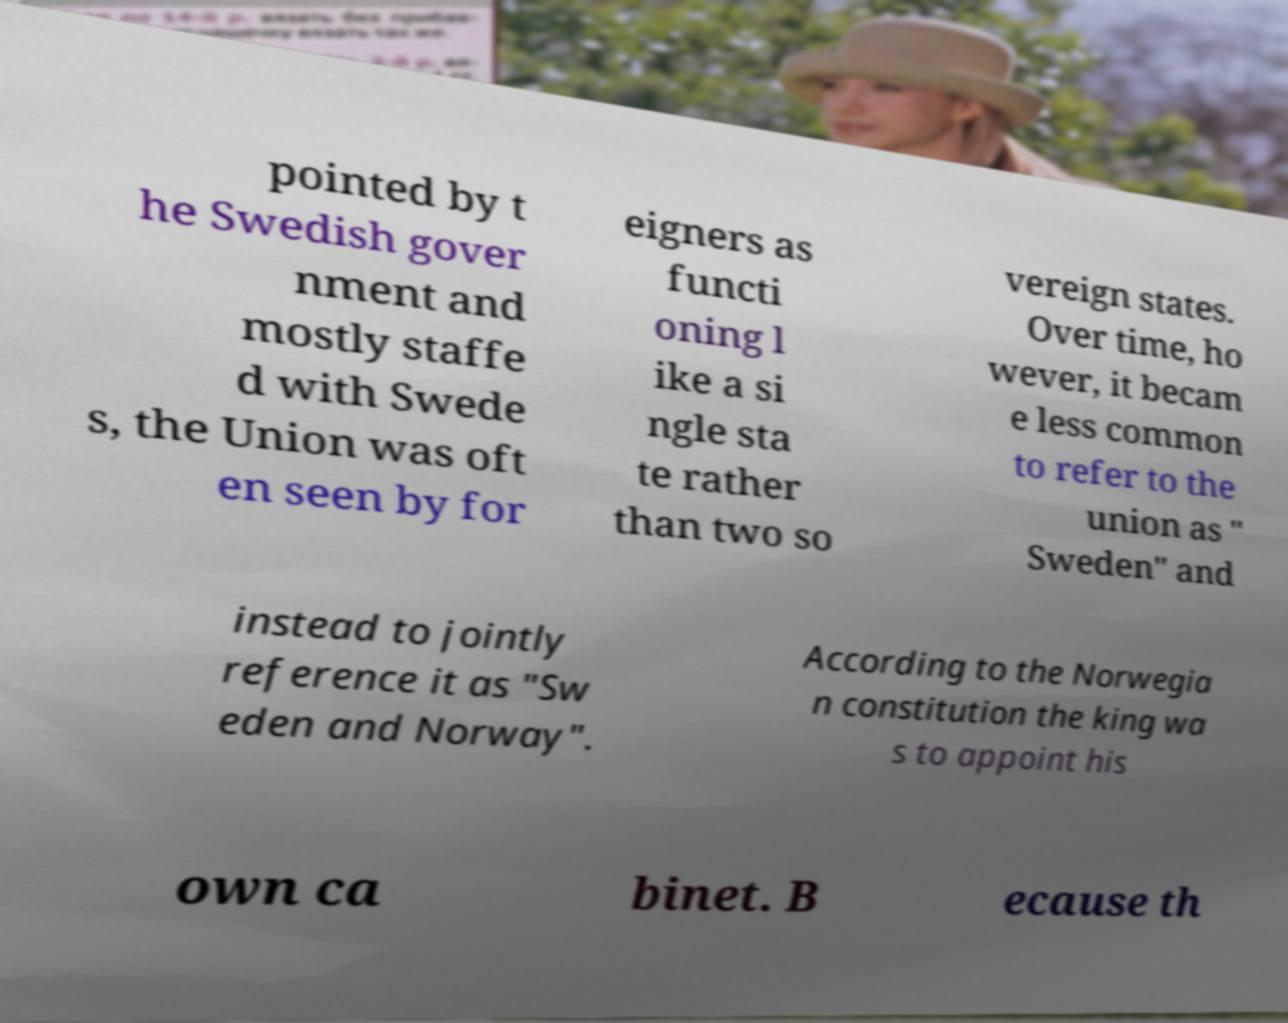Could you extract and type out the text from this image? pointed by t he Swedish gover nment and mostly staffe d with Swede s, the Union was oft en seen by for eigners as functi oning l ike a si ngle sta te rather than two so vereign states. Over time, ho wever, it becam e less common to refer to the union as " Sweden" and instead to jointly reference it as "Sw eden and Norway". According to the Norwegia n constitution the king wa s to appoint his own ca binet. B ecause th 